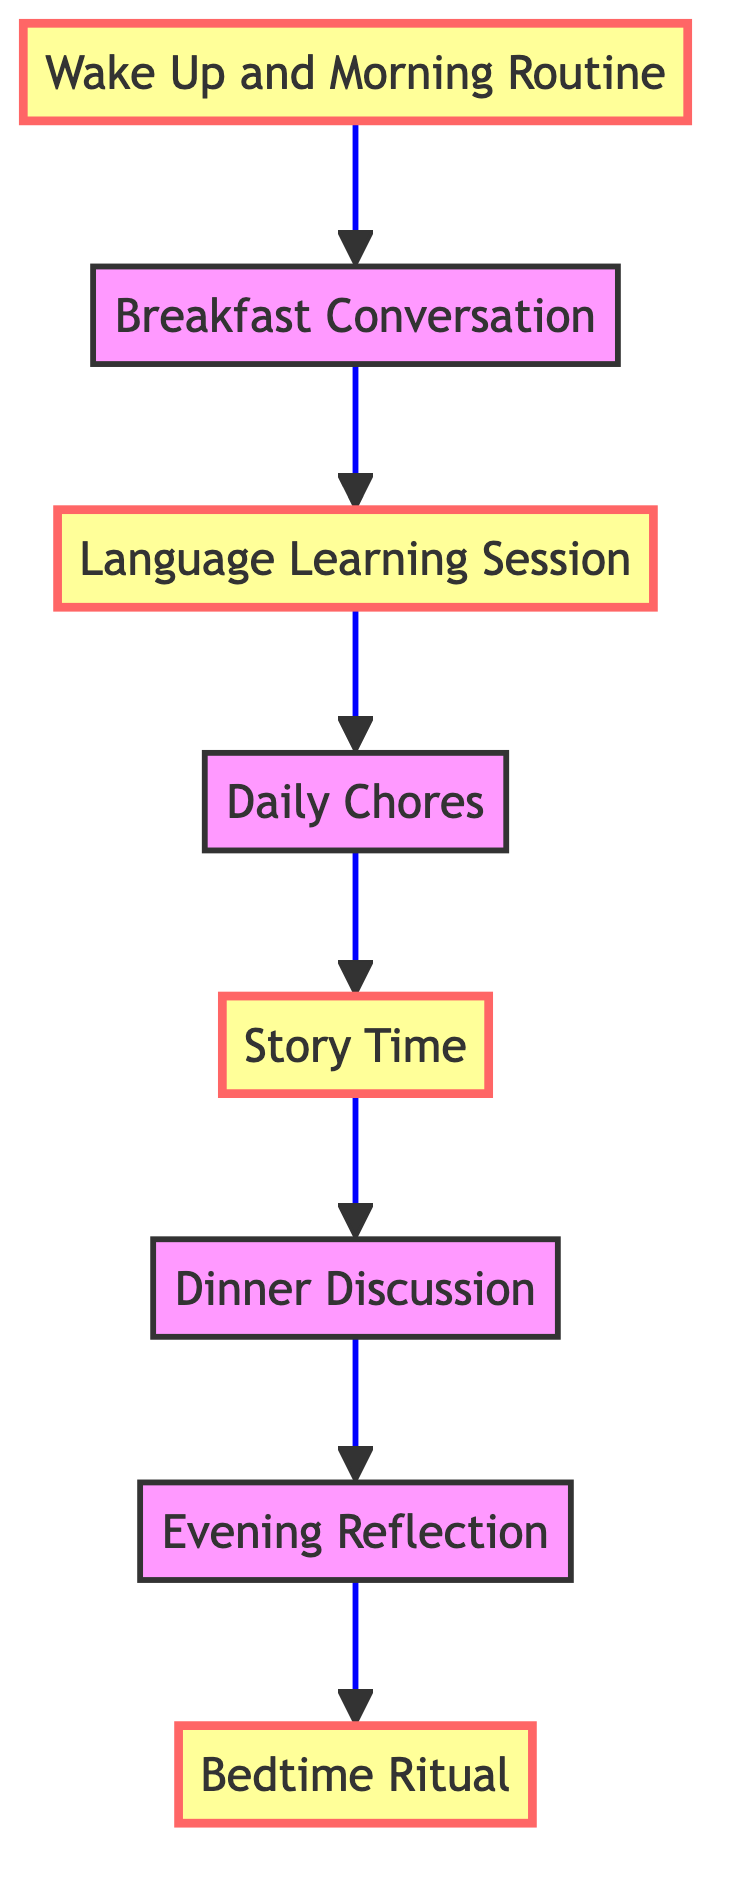What is the first activity in the daily routine? The first activity in the flow chart is "Wake Up and Morning Routine," which is indicated as the starting point with an arrow leading to the next step.
Answer: Wake Up and Morning Routine How many activities are in the daily routine? By counting the nodes listed in the flow chart, there are a total of eight activities from the start of the routine to the end.
Answer: Eight What follows the "Language Learning Session"? The flow chart connects "Language Learning Session" directly to "Daily Chores," as shown by the arrow indicating the next step in the sequence.
Answer: Daily Chores What is the last activity in the daily routine? The last node in the flow chart lists "Bedtime Ritual," which concludes the daily routine with no further connections.
Answer: Bedtime Ritual Which activity involves discussing the day’s learning? The flow chart specifies that "Dinner Discussion" is the activity where family members share what they learned during the day and discusses it exclusively in their Indigenous language.
Answer: Dinner Discussion How many activities involve reading or listening? There are two activities in the flow chart that involve reading or listening: "Story Time" and the implied sharing during "Dinner Discussion," focusing on learned experiences.
Answer: Two What is the common feature of the highlighted nodes? The highlighted nodes in the diagram ("Wake Up and Morning Routine," "Language Learning Session," "Story Time," and "Bedtime Ritual") signify key activities that emphasize interaction with the Indigenous language throughout the day.
Answer: Key activities Which activity specifically mentions using a language learning app? The flow chart indicates that the "Language Learning Session" explicitly focuses on learning new vocabulary and phrases using either a language learning app or a book dedicated to the Indigenous language.
Answer: Language Learning Session What action is taken during "Evening Reflection"? The diagram states that "Evening Reflection" involves reflecting on the day's learning, where individuals write a diary entry or record a voice note in their Indigenous language to reinforce the usage of the language.
Answer: Reflecting and recording 